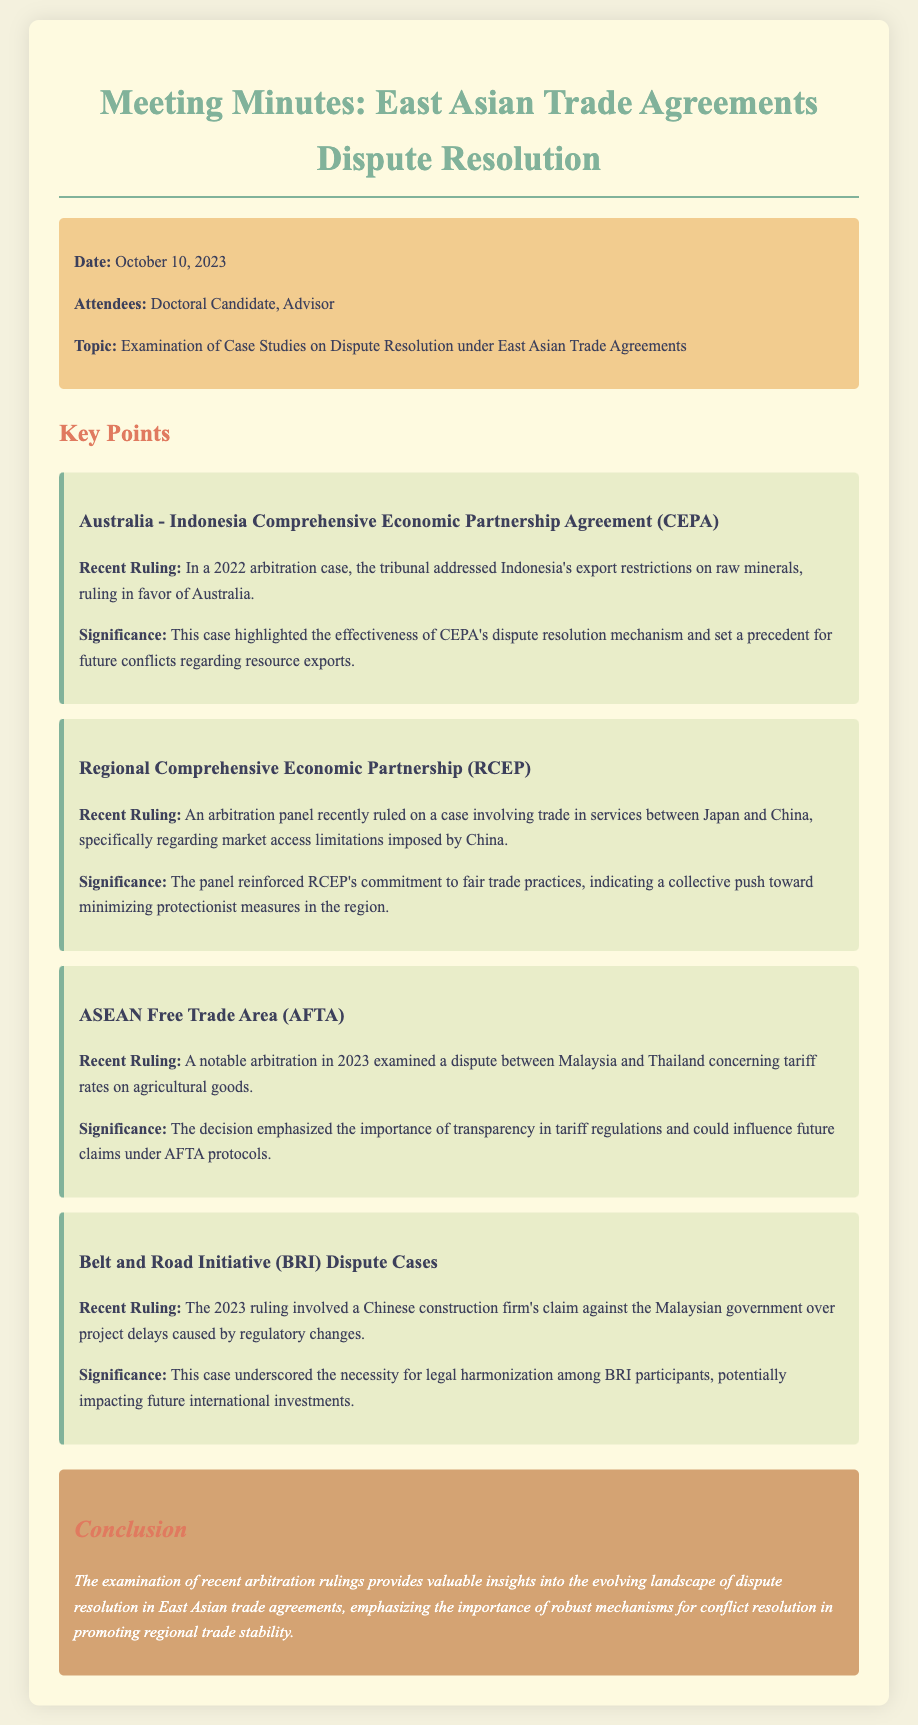what is the date of the meeting? The date of the meeting is mentioned in the meta-info section of the document.
Answer: October 10, 2023 who are the attendees listed in the meeting minutes? The attendees are specified in the meta-info section of the document.
Answer: Doctoral Candidate, Advisor which case involved Indonesia's export restrictions? The case concerning Indonesia's export restrictions is detailed under the Australia - Indonesia Comprehensive Economic Partnership Agreement section.
Answer: Australia - Indonesia Comprehensive Economic Partnership Agreement (CEPA) what recent ruling was made regarding tariff rates on agricultural goods? The recent ruling regarding tariff rates is mentioned under the ASEAN Free Trade Area (AFTA) section of the document.
Answer: A dispute between Malaysia and Thailand why is the recent ruling on trade in services significant? The significance of the ruling on trade in services is provided in the Regional Comprehensive Economic Partnership (RCEP) section, discussing fair trade practices.
Answer: Minimize protectionist measures what overarching theme does the conclusion highlight? The conclusion summarizes the findings of the meeting minutes and discusses the implications for dispute resolution.
Answer: Robust mechanisms for conflict resolution 